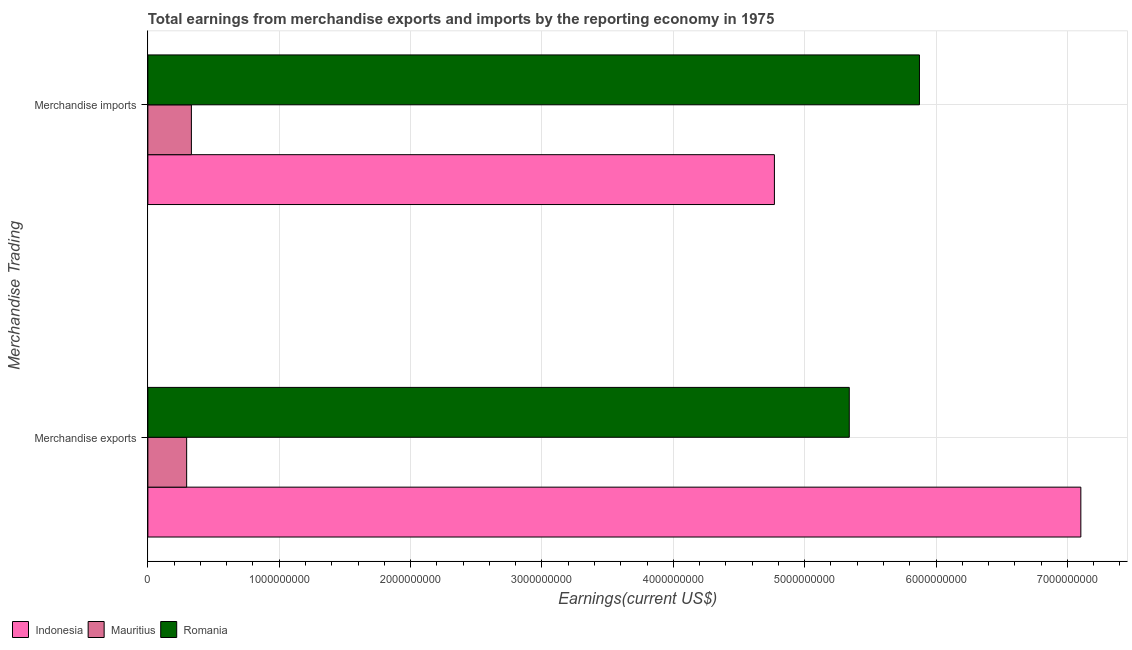How many different coloured bars are there?
Offer a very short reply. 3. Are the number of bars on each tick of the Y-axis equal?
Keep it short and to the point. Yes. How many bars are there on the 1st tick from the bottom?
Ensure brevity in your answer.  3. What is the label of the 1st group of bars from the top?
Keep it short and to the point. Merchandise imports. What is the earnings from merchandise imports in Indonesia?
Ensure brevity in your answer.  4.77e+09. Across all countries, what is the maximum earnings from merchandise imports?
Make the answer very short. 5.87e+09. Across all countries, what is the minimum earnings from merchandise exports?
Make the answer very short. 2.95e+08. In which country was the earnings from merchandise exports minimum?
Make the answer very short. Mauritius. What is the total earnings from merchandise exports in the graph?
Give a very brief answer. 1.27e+1. What is the difference between the earnings from merchandise imports in Romania and that in Indonesia?
Provide a succinct answer. 1.10e+09. What is the difference between the earnings from merchandise exports in Romania and the earnings from merchandise imports in Mauritius?
Your response must be concise. 5.01e+09. What is the average earnings from merchandise imports per country?
Your answer should be compact. 3.66e+09. What is the difference between the earnings from merchandise exports and earnings from merchandise imports in Indonesia?
Keep it short and to the point. 2.33e+09. What is the ratio of the earnings from merchandise imports in Indonesia to that in Mauritius?
Offer a very short reply. 14.39. What does the 2nd bar from the bottom in Merchandise exports represents?
Offer a terse response. Mauritius. How many bars are there?
Your response must be concise. 6. How many countries are there in the graph?
Make the answer very short. 3. Where does the legend appear in the graph?
Give a very brief answer. Bottom left. How many legend labels are there?
Make the answer very short. 3. What is the title of the graph?
Offer a very short reply. Total earnings from merchandise exports and imports by the reporting economy in 1975. What is the label or title of the X-axis?
Offer a very short reply. Earnings(current US$). What is the label or title of the Y-axis?
Ensure brevity in your answer.  Merchandise Trading. What is the Earnings(current US$) in Indonesia in Merchandise exports?
Offer a very short reply. 7.10e+09. What is the Earnings(current US$) of Mauritius in Merchandise exports?
Your answer should be very brief. 2.95e+08. What is the Earnings(current US$) of Romania in Merchandise exports?
Give a very brief answer. 5.34e+09. What is the Earnings(current US$) in Indonesia in Merchandise imports?
Keep it short and to the point. 4.77e+09. What is the Earnings(current US$) of Mauritius in Merchandise imports?
Your response must be concise. 3.31e+08. What is the Earnings(current US$) of Romania in Merchandise imports?
Offer a terse response. 5.87e+09. Across all Merchandise Trading, what is the maximum Earnings(current US$) in Indonesia?
Your response must be concise. 7.10e+09. Across all Merchandise Trading, what is the maximum Earnings(current US$) of Mauritius?
Provide a short and direct response. 3.31e+08. Across all Merchandise Trading, what is the maximum Earnings(current US$) in Romania?
Your answer should be compact. 5.87e+09. Across all Merchandise Trading, what is the minimum Earnings(current US$) in Indonesia?
Your response must be concise. 4.77e+09. Across all Merchandise Trading, what is the minimum Earnings(current US$) in Mauritius?
Ensure brevity in your answer.  2.95e+08. Across all Merchandise Trading, what is the minimum Earnings(current US$) of Romania?
Offer a very short reply. 5.34e+09. What is the total Earnings(current US$) in Indonesia in the graph?
Provide a succinct answer. 1.19e+1. What is the total Earnings(current US$) of Mauritius in the graph?
Provide a succinct answer. 6.27e+08. What is the total Earnings(current US$) in Romania in the graph?
Provide a succinct answer. 1.12e+1. What is the difference between the Earnings(current US$) in Indonesia in Merchandise exports and that in Merchandise imports?
Give a very brief answer. 2.33e+09. What is the difference between the Earnings(current US$) of Mauritius in Merchandise exports and that in Merchandise imports?
Your response must be concise. -3.61e+07. What is the difference between the Earnings(current US$) of Romania in Merchandise exports and that in Merchandise imports?
Offer a terse response. -5.34e+08. What is the difference between the Earnings(current US$) of Indonesia in Merchandise exports and the Earnings(current US$) of Mauritius in Merchandise imports?
Give a very brief answer. 6.77e+09. What is the difference between the Earnings(current US$) in Indonesia in Merchandise exports and the Earnings(current US$) in Romania in Merchandise imports?
Keep it short and to the point. 1.23e+09. What is the difference between the Earnings(current US$) in Mauritius in Merchandise exports and the Earnings(current US$) in Romania in Merchandise imports?
Offer a terse response. -5.58e+09. What is the average Earnings(current US$) of Indonesia per Merchandise Trading?
Provide a short and direct response. 5.94e+09. What is the average Earnings(current US$) in Mauritius per Merchandise Trading?
Offer a terse response. 3.13e+08. What is the average Earnings(current US$) in Romania per Merchandise Trading?
Give a very brief answer. 5.61e+09. What is the difference between the Earnings(current US$) in Indonesia and Earnings(current US$) in Mauritius in Merchandise exports?
Provide a succinct answer. 6.81e+09. What is the difference between the Earnings(current US$) in Indonesia and Earnings(current US$) in Romania in Merchandise exports?
Offer a very short reply. 1.76e+09. What is the difference between the Earnings(current US$) of Mauritius and Earnings(current US$) of Romania in Merchandise exports?
Your answer should be very brief. -5.04e+09. What is the difference between the Earnings(current US$) in Indonesia and Earnings(current US$) in Mauritius in Merchandise imports?
Give a very brief answer. 4.44e+09. What is the difference between the Earnings(current US$) in Indonesia and Earnings(current US$) in Romania in Merchandise imports?
Ensure brevity in your answer.  -1.10e+09. What is the difference between the Earnings(current US$) in Mauritius and Earnings(current US$) in Romania in Merchandise imports?
Offer a terse response. -5.54e+09. What is the ratio of the Earnings(current US$) in Indonesia in Merchandise exports to that in Merchandise imports?
Ensure brevity in your answer.  1.49. What is the ratio of the Earnings(current US$) in Mauritius in Merchandise exports to that in Merchandise imports?
Provide a succinct answer. 0.89. What is the ratio of the Earnings(current US$) of Romania in Merchandise exports to that in Merchandise imports?
Make the answer very short. 0.91. What is the difference between the highest and the second highest Earnings(current US$) of Indonesia?
Offer a terse response. 2.33e+09. What is the difference between the highest and the second highest Earnings(current US$) in Mauritius?
Your answer should be compact. 3.61e+07. What is the difference between the highest and the second highest Earnings(current US$) in Romania?
Your answer should be very brief. 5.34e+08. What is the difference between the highest and the lowest Earnings(current US$) in Indonesia?
Make the answer very short. 2.33e+09. What is the difference between the highest and the lowest Earnings(current US$) of Mauritius?
Offer a terse response. 3.61e+07. What is the difference between the highest and the lowest Earnings(current US$) in Romania?
Your answer should be very brief. 5.34e+08. 